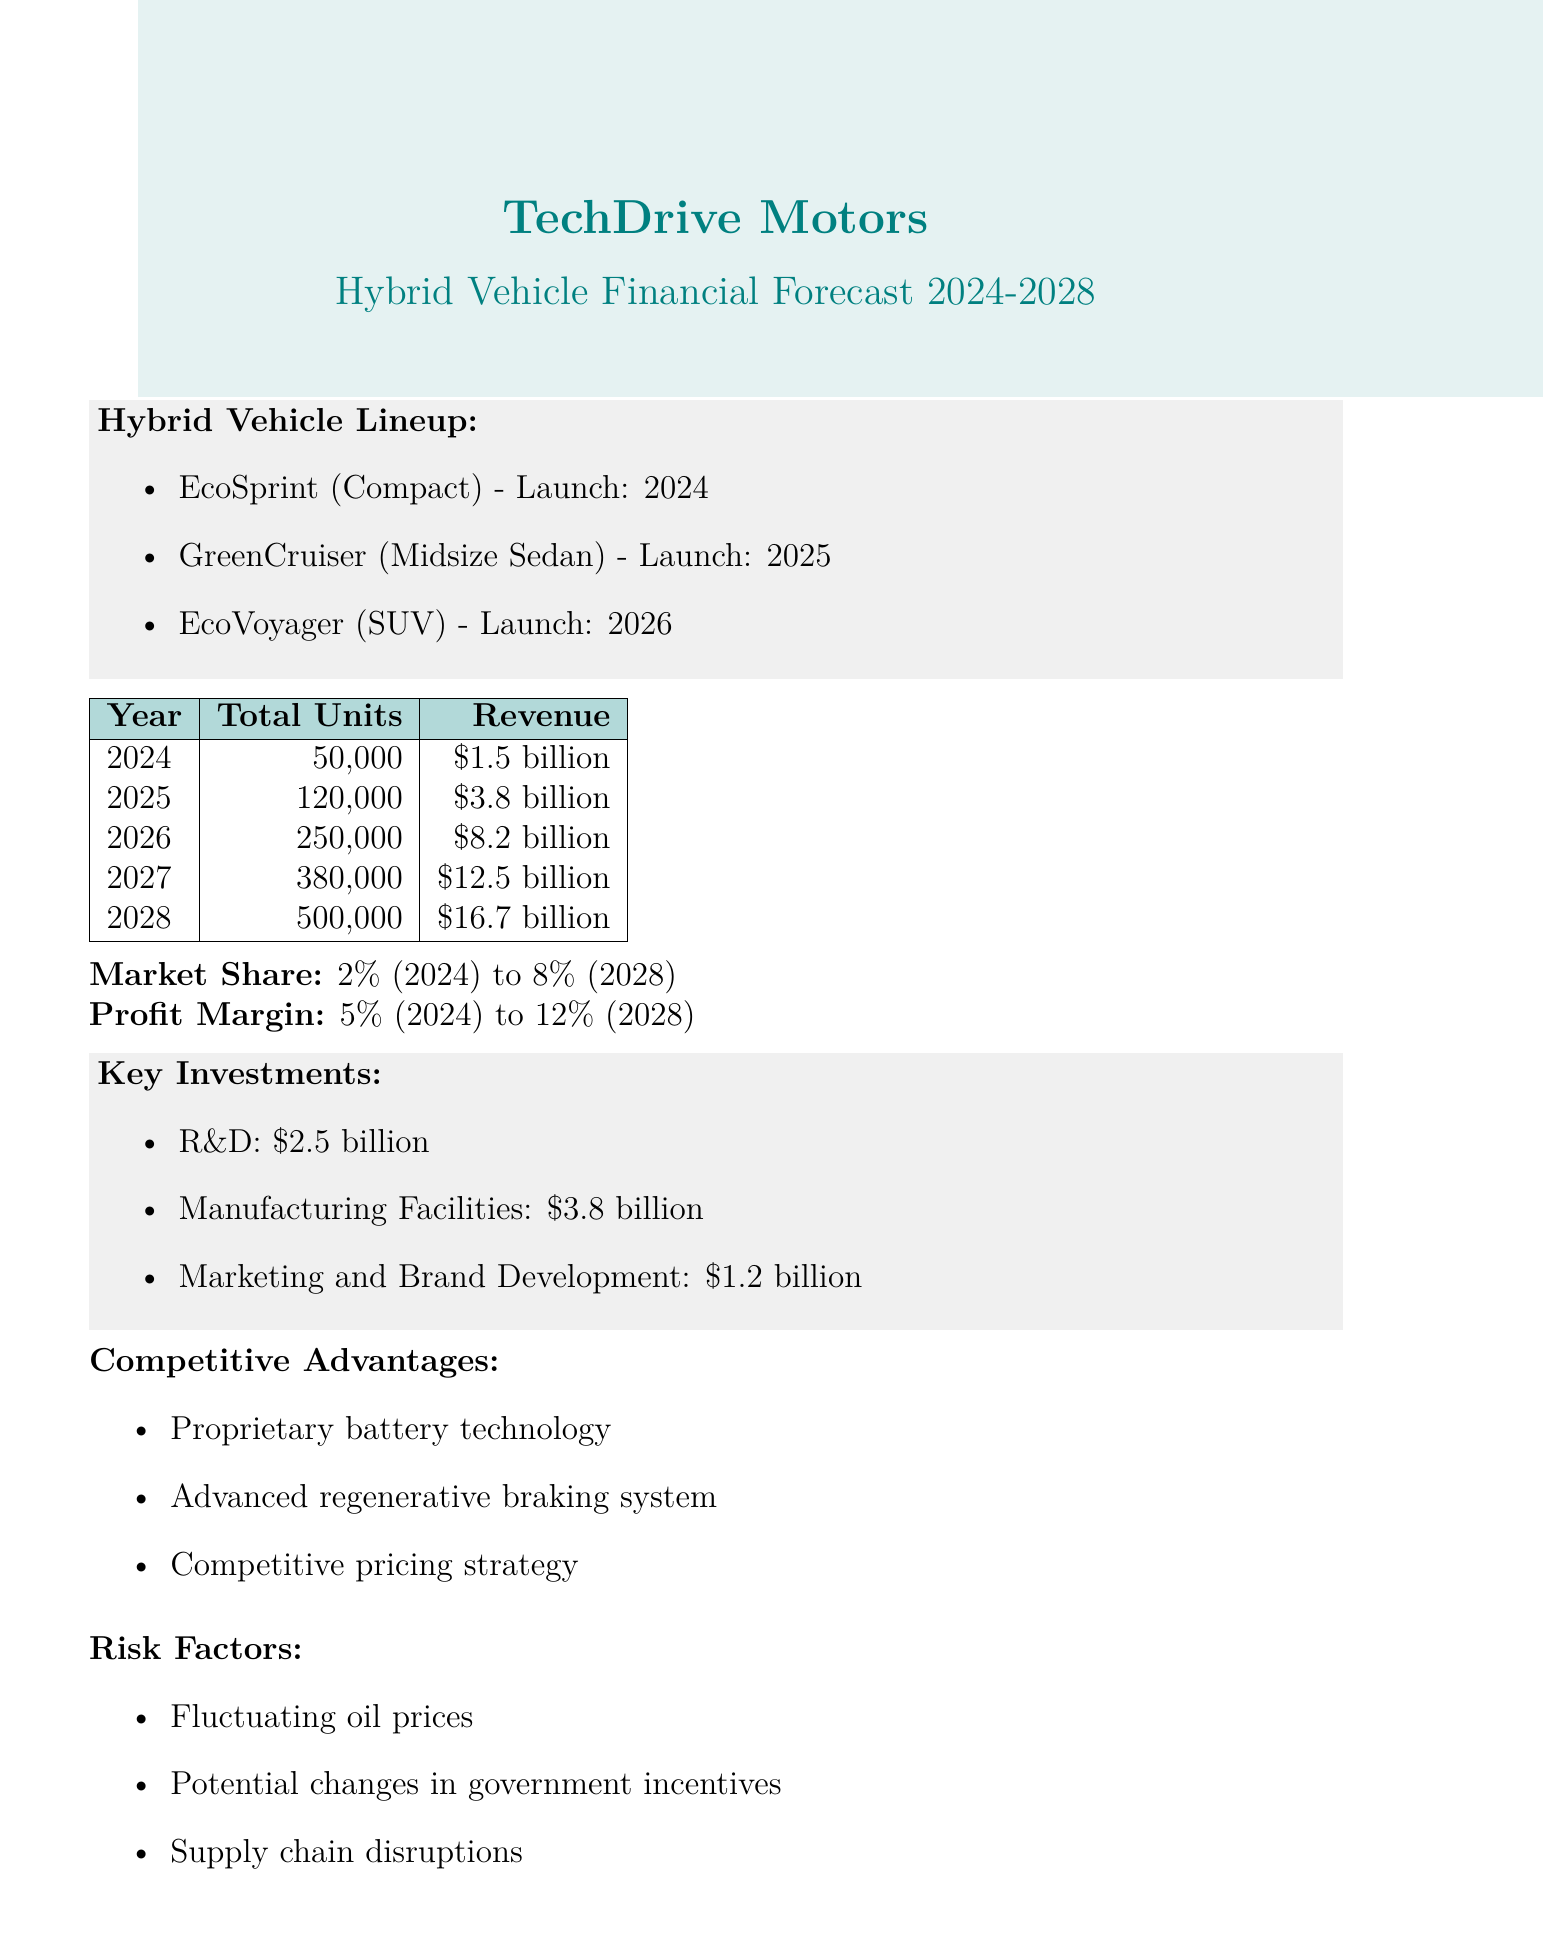what is the model name of the compact hybrid vehicle? The document specifies the compact hybrid vehicle as EcoSprint.
Answer: EcoSprint what is the projected total units sold in 2026? The total units sold in 2026 as stated in the document is 250,000.
Answer: 250000 what is the revenue forecast for the year 2025? The forecasted revenue for 2025 provided in the document is $3.8 billion.
Answer: $3.8 billion what is the target profit margin by 2028? The document indicates that the profit margin is expected to reach 12% by 2028.
Answer: 12% what is the total number of units expected to be sold in 2027? The document projects a total of 380,000 units to be sold in 2027.
Answer: 380000 what investment area has the highest funding? Among the key investments listed, manufacturing facilities have the highest funding of $3.8 billion.
Answer: Manufacturing Facilities what is the market share projected for 2024? The projected market share for 2024 in the document is 2%.
Answer: 2% name one competitive advantage mentioned in the document. One of the competitive advantages highlighted is proprietary battery technology.
Answer: Proprietary battery technology what are two of the risk factors identified? The document lists fluctuating oil prices and potential changes in government incentives as risk factors.
Answer: Fluctuating oil prices, potential changes in government incentives 